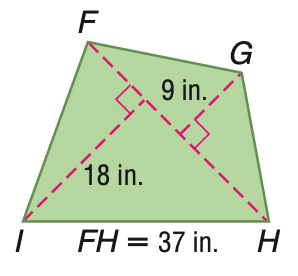Question: Find the area of the quadrilateral.
Choices:
A. 405
B. 499.5
C. 684.5
D. 999
Answer with the letter. Answer: B 